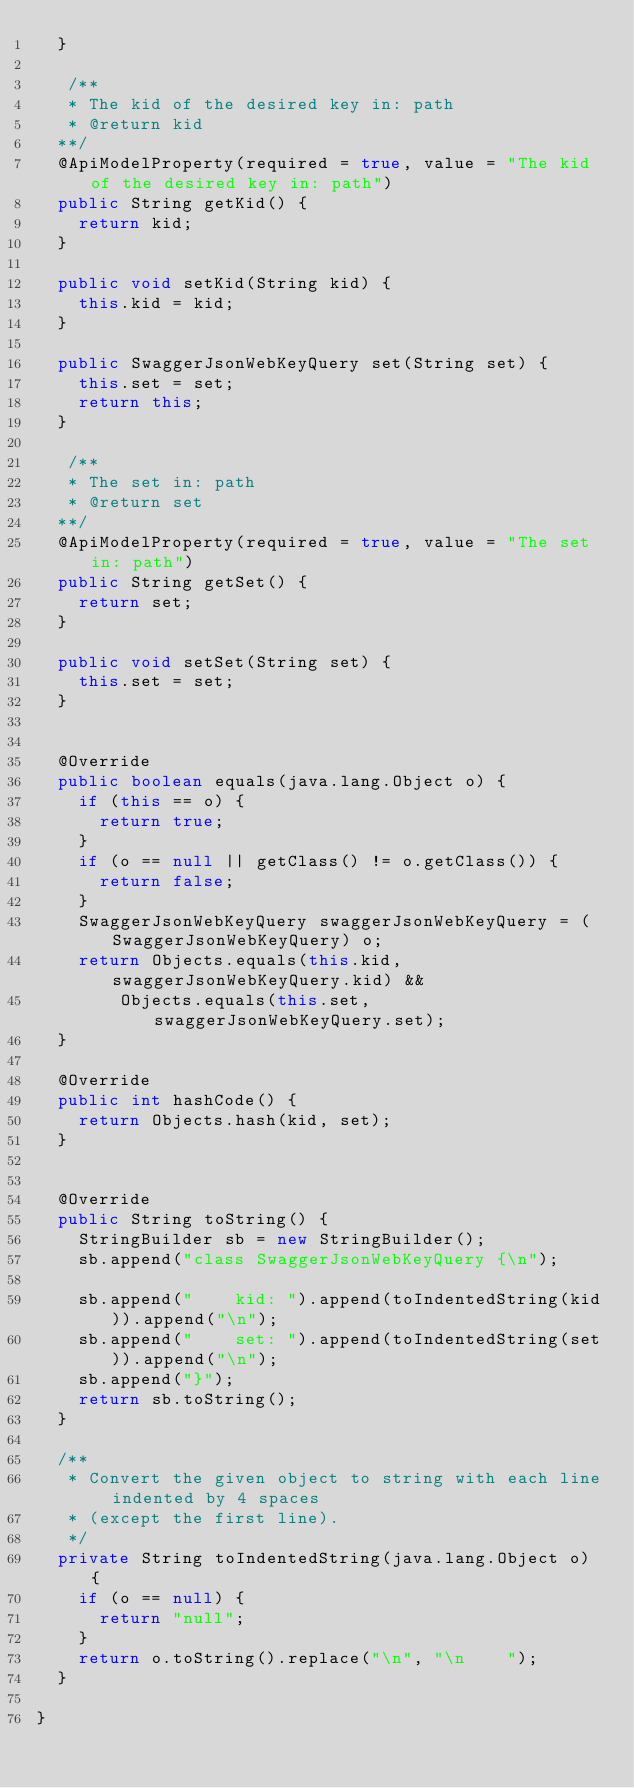Convert code to text. <code><loc_0><loc_0><loc_500><loc_500><_Java_>  }

   /**
   * The kid of the desired key in: path
   * @return kid
  **/
  @ApiModelProperty(required = true, value = "The kid of the desired key in: path")
  public String getKid() {
    return kid;
  }

  public void setKid(String kid) {
    this.kid = kid;
  }

  public SwaggerJsonWebKeyQuery set(String set) {
    this.set = set;
    return this;
  }

   /**
   * The set in: path
   * @return set
  **/
  @ApiModelProperty(required = true, value = "The set in: path")
  public String getSet() {
    return set;
  }

  public void setSet(String set) {
    this.set = set;
  }


  @Override
  public boolean equals(java.lang.Object o) {
    if (this == o) {
      return true;
    }
    if (o == null || getClass() != o.getClass()) {
      return false;
    }
    SwaggerJsonWebKeyQuery swaggerJsonWebKeyQuery = (SwaggerJsonWebKeyQuery) o;
    return Objects.equals(this.kid, swaggerJsonWebKeyQuery.kid) &&
        Objects.equals(this.set, swaggerJsonWebKeyQuery.set);
  }

  @Override
  public int hashCode() {
    return Objects.hash(kid, set);
  }


  @Override
  public String toString() {
    StringBuilder sb = new StringBuilder();
    sb.append("class SwaggerJsonWebKeyQuery {\n");
    
    sb.append("    kid: ").append(toIndentedString(kid)).append("\n");
    sb.append("    set: ").append(toIndentedString(set)).append("\n");
    sb.append("}");
    return sb.toString();
  }

  /**
   * Convert the given object to string with each line indented by 4 spaces
   * (except the first line).
   */
  private String toIndentedString(java.lang.Object o) {
    if (o == null) {
      return "null";
    }
    return o.toString().replace("\n", "\n    ");
  }
  
}

</code> 